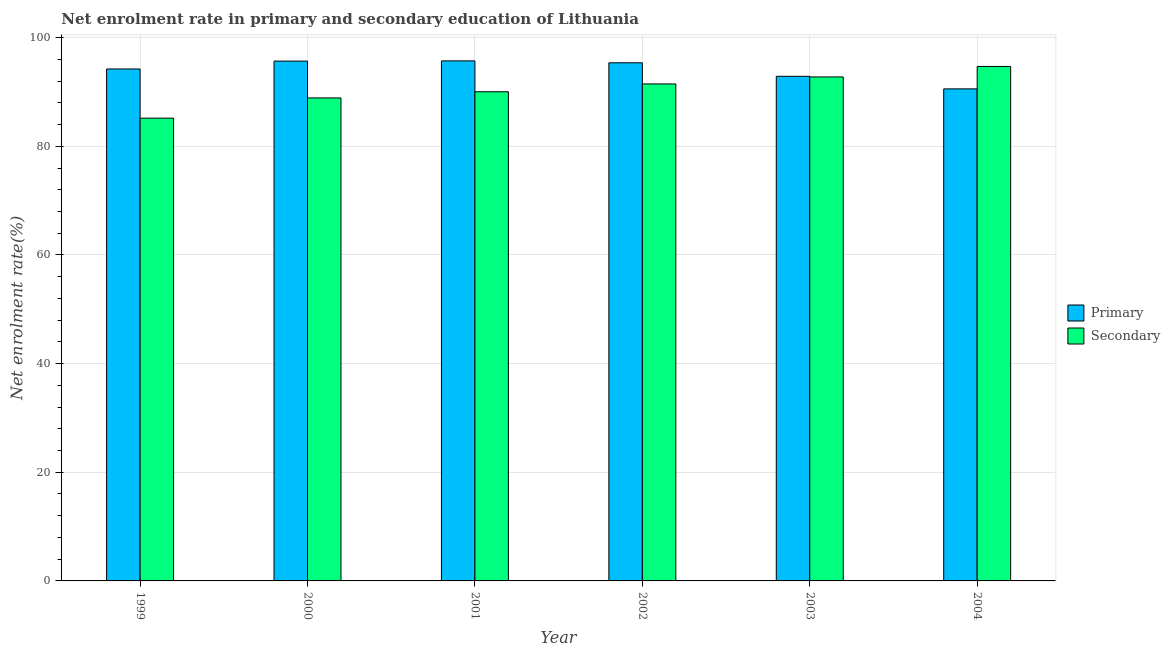How many groups of bars are there?
Offer a very short reply. 6. Are the number of bars per tick equal to the number of legend labels?
Provide a short and direct response. Yes. Are the number of bars on each tick of the X-axis equal?
Give a very brief answer. Yes. How many bars are there on the 2nd tick from the right?
Keep it short and to the point. 2. What is the label of the 4th group of bars from the left?
Offer a very short reply. 2002. In how many cases, is the number of bars for a given year not equal to the number of legend labels?
Give a very brief answer. 0. What is the enrollment rate in secondary education in 2002?
Offer a terse response. 91.47. Across all years, what is the maximum enrollment rate in primary education?
Make the answer very short. 95.72. Across all years, what is the minimum enrollment rate in primary education?
Your response must be concise. 90.56. In which year was the enrollment rate in secondary education maximum?
Offer a terse response. 2004. In which year was the enrollment rate in secondary education minimum?
Your answer should be compact. 1999. What is the total enrollment rate in primary education in the graph?
Offer a very short reply. 564.43. What is the difference between the enrollment rate in secondary education in 1999 and that in 2003?
Ensure brevity in your answer.  -7.59. What is the difference between the enrollment rate in secondary education in 2001 and the enrollment rate in primary education in 2002?
Give a very brief answer. -1.44. What is the average enrollment rate in primary education per year?
Provide a short and direct response. 94.07. In the year 2000, what is the difference between the enrollment rate in primary education and enrollment rate in secondary education?
Your response must be concise. 0. In how many years, is the enrollment rate in secondary education greater than 88 %?
Your response must be concise. 5. What is the ratio of the enrollment rate in secondary education in 2001 to that in 2003?
Your response must be concise. 0.97. Is the enrollment rate in primary education in 2000 less than that in 2001?
Provide a succinct answer. Yes. Is the difference between the enrollment rate in primary education in 2000 and 2004 greater than the difference between the enrollment rate in secondary education in 2000 and 2004?
Offer a very short reply. No. What is the difference between the highest and the second highest enrollment rate in secondary education?
Ensure brevity in your answer.  1.93. What is the difference between the highest and the lowest enrollment rate in secondary education?
Provide a succinct answer. 9.52. In how many years, is the enrollment rate in secondary education greater than the average enrollment rate in secondary education taken over all years?
Provide a succinct answer. 3. Is the sum of the enrollment rate in primary education in 2000 and 2001 greater than the maximum enrollment rate in secondary education across all years?
Provide a short and direct response. Yes. What does the 1st bar from the left in 2003 represents?
Offer a very short reply. Primary. What does the 2nd bar from the right in 2003 represents?
Your answer should be very brief. Primary. Are all the bars in the graph horizontal?
Your answer should be very brief. No. What is the difference between two consecutive major ticks on the Y-axis?
Your answer should be very brief. 20. Does the graph contain any zero values?
Provide a succinct answer. No. Where does the legend appear in the graph?
Keep it short and to the point. Center right. How many legend labels are there?
Ensure brevity in your answer.  2. What is the title of the graph?
Offer a very short reply. Net enrolment rate in primary and secondary education of Lithuania. What is the label or title of the Y-axis?
Your answer should be compact. Net enrolment rate(%). What is the Net enrolment rate(%) in Primary in 1999?
Your answer should be compact. 94.23. What is the Net enrolment rate(%) in Secondary in 1999?
Your answer should be very brief. 85.17. What is the Net enrolment rate(%) of Primary in 2000?
Provide a succinct answer. 95.68. What is the Net enrolment rate(%) in Secondary in 2000?
Provide a short and direct response. 88.9. What is the Net enrolment rate(%) of Primary in 2001?
Make the answer very short. 95.72. What is the Net enrolment rate(%) of Secondary in 2001?
Give a very brief answer. 90.03. What is the Net enrolment rate(%) in Primary in 2002?
Ensure brevity in your answer.  95.37. What is the Net enrolment rate(%) in Secondary in 2002?
Your answer should be very brief. 91.47. What is the Net enrolment rate(%) of Primary in 2003?
Ensure brevity in your answer.  92.88. What is the Net enrolment rate(%) of Secondary in 2003?
Make the answer very short. 92.76. What is the Net enrolment rate(%) in Primary in 2004?
Offer a terse response. 90.56. What is the Net enrolment rate(%) in Secondary in 2004?
Your answer should be very brief. 94.69. Across all years, what is the maximum Net enrolment rate(%) in Primary?
Provide a short and direct response. 95.72. Across all years, what is the maximum Net enrolment rate(%) in Secondary?
Make the answer very short. 94.69. Across all years, what is the minimum Net enrolment rate(%) in Primary?
Your answer should be very brief. 90.56. Across all years, what is the minimum Net enrolment rate(%) in Secondary?
Offer a very short reply. 85.17. What is the total Net enrolment rate(%) in Primary in the graph?
Ensure brevity in your answer.  564.43. What is the total Net enrolment rate(%) in Secondary in the graph?
Your answer should be compact. 543.03. What is the difference between the Net enrolment rate(%) in Primary in 1999 and that in 2000?
Your response must be concise. -1.45. What is the difference between the Net enrolment rate(%) of Secondary in 1999 and that in 2000?
Keep it short and to the point. -3.73. What is the difference between the Net enrolment rate(%) of Primary in 1999 and that in 2001?
Ensure brevity in your answer.  -1.49. What is the difference between the Net enrolment rate(%) in Secondary in 1999 and that in 2001?
Your answer should be compact. -4.86. What is the difference between the Net enrolment rate(%) of Primary in 1999 and that in 2002?
Your answer should be very brief. -1.14. What is the difference between the Net enrolment rate(%) in Secondary in 1999 and that in 2002?
Keep it short and to the point. -6.3. What is the difference between the Net enrolment rate(%) in Primary in 1999 and that in 2003?
Offer a very short reply. 1.35. What is the difference between the Net enrolment rate(%) in Secondary in 1999 and that in 2003?
Keep it short and to the point. -7.59. What is the difference between the Net enrolment rate(%) in Primary in 1999 and that in 2004?
Provide a succinct answer. 3.66. What is the difference between the Net enrolment rate(%) of Secondary in 1999 and that in 2004?
Ensure brevity in your answer.  -9.52. What is the difference between the Net enrolment rate(%) in Primary in 2000 and that in 2001?
Provide a short and direct response. -0.04. What is the difference between the Net enrolment rate(%) of Secondary in 2000 and that in 2001?
Offer a terse response. -1.14. What is the difference between the Net enrolment rate(%) of Primary in 2000 and that in 2002?
Your answer should be very brief. 0.31. What is the difference between the Net enrolment rate(%) of Secondary in 2000 and that in 2002?
Your answer should be very brief. -2.57. What is the difference between the Net enrolment rate(%) of Primary in 2000 and that in 2003?
Keep it short and to the point. 2.8. What is the difference between the Net enrolment rate(%) in Secondary in 2000 and that in 2003?
Provide a succinct answer. -3.86. What is the difference between the Net enrolment rate(%) of Primary in 2000 and that in 2004?
Keep it short and to the point. 5.11. What is the difference between the Net enrolment rate(%) in Secondary in 2000 and that in 2004?
Give a very brief answer. -5.79. What is the difference between the Net enrolment rate(%) of Primary in 2001 and that in 2002?
Ensure brevity in your answer.  0.35. What is the difference between the Net enrolment rate(%) of Secondary in 2001 and that in 2002?
Provide a succinct answer. -1.44. What is the difference between the Net enrolment rate(%) in Primary in 2001 and that in 2003?
Provide a succinct answer. 2.84. What is the difference between the Net enrolment rate(%) in Secondary in 2001 and that in 2003?
Provide a succinct answer. -2.73. What is the difference between the Net enrolment rate(%) of Primary in 2001 and that in 2004?
Give a very brief answer. 5.16. What is the difference between the Net enrolment rate(%) of Secondary in 2001 and that in 2004?
Provide a succinct answer. -4.65. What is the difference between the Net enrolment rate(%) in Primary in 2002 and that in 2003?
Offer a very short reply. 2.49. What is the difference between the Net enrolment rate(%) of Secondary in 2002 and that in 2003?
Keep it short and to the point. -1.29. What is the difference between the Net enrolment rate(%) of Primary in 2002 and that in 2004?
Ensure brevity in your answer.  4.8. What is the difference between the Net enrolment rate(%) in Secondary in 2002 and that in 2004?
Keep it short and to the point. -3.22. What is the difference between the Net enrolment rate(%) of Primary in 2003 and that in 2004?
Your answer should be very brief. 2.32. What is the difference between the Net enrolment rate(%) in Secondary in 2003 and that in 2004?
Offer a terse response. -1.93. What is the difference between the Net enrolment rate(%) of Primary in 1999 and the Net enrolment rate(%) of Secondary in 2000?
Offer a terse response. 5.33. What is the difference between the Net enrolment rate(%) of Primary in 1999 and the Net enrolment rate(%) of Secondary in 2001?
Your answer should be compact. 4.19. What is the difference between the Net enrolment rate(%) in Primary in 1999 and the Net enrolment rate(%) in Secondary in 2002?
Provide a succinct answer. 2.75. What is the difference between the Net enrolment rate(%) of Primary in 1999 and the Net enrolment rate(%) of Secondary in 2003?
Make the answer very short. 1.46. What is the difference between the Net enrolment rate(%) of Primary in 1999 and the Net enrolment rate(%) of Secondary in 2004?
Give a very brief answer. -0.46. What is the difference between the Net enrolment rate(%) in Primary in 2000 and the Net enrolment rate(%) in Secondary in 2001?
Give a very brief answer. 5.64. What is the difference between the Net enrolment rate(%) of Primary in 2000 and the Net enrolment rate(%) of Secondary in 2002?
Your response must be concise. 4.2. What is the difference between the Net enrolment rate(%) in Primary in 2000 and the Net enrolment rate(%) in Secondary in 2003?
Make the answer very short. 2.91. What is the difference between the Net enrolment rate(%) in Primary in 2000 and the Net enrolment rate(%) in Secondary in 2004?
Ensure brevity in your answer.  0.99. What is the difference between the Net enrolment rate(%) in Primary in 2001 and the Net enrolment rate(%) in Secondary in 2002?
Give a very brief answer. 4.25. What is the difference between the Net enrolment rate(%) in Primary in 2001 and the Net enrolment rate(%) in Secondary in 2003?
Your answer should be very brief. 2.96. What is the difference between the Net enrolment rate(%) of Primary in 2001 and the Net enrolment rate(%) of Secondary in 2004?
Ensure brevity in your answer.  1.03. What is the difference between the Net enrolment rate(%) of Primary in 2002 and the Net enrolment rate(%) of Secondary in 2003?
Provide a short and direct response. 2.6. What is the difference between the Net enrolment rate(%) of Primary in 2002 and the Net enrolment rate(%) of Secondary in 2004?
Offer a terse response. 0.68. What is the difference between the Net enrolment rate(%) in Primary in 2003 and the Net enrolment rate(%) in Secondary in 2004?
Make the answer very short. -1.81. What is the average Net enrolment rate(%) in Primary per year?
Give a very brief answer. 94.07. What is the average Net enrolment rate(%) in Secondary per year?
Give a very brief answer. 90.51. In the year 1999, what is the difference between the Net enrolment rate(%) in Primary and Net enrolment rate(%) in Secondary?
Ensure brevity in your answer.  9.05. In the year 2000, what is the difference between the Net enrolment rate(%) in Primary and Net enrolment rate(%) in Secondary?
Make the answer very short. 6.78. In the year 2001, what is the difference between the Net enrolment rate(%) of Primary and Net enrolment rate(%) of Secondary?
Make the answer very short. 5.68. In the year 2002, what is the difference between the Net enrolment rate(%) in Primary and Net enrolment rate(%) in Secondary?
Your response must be concise. 3.89. In the year 2003, what is the difference between the Net enrolment rate(%) of Primary and Net enrolment rate(%) of Secondary?
Offer a terse response. 0.12. In the year 2004, what is the difference between the Net enrolment rate(%) of Primary and Net enrolment rate(%) of Secondary?
Your answer should be compact. -4.13. What is the ratio of the Net enrolment rate(%) of Primary in 1999 to that in 2000?
Give a very brief answer. 0.98. What is the ratio of the Net enrolment rate(%) of Secondary in 1999 to that in 2000?
Give a very brief answer. 0.96. What is the ratio of the Net enrolment rate(%) in Primary in 1999 to that in 2001?
Keep it short and to the point. 0.98. What is the ratio of the Net enrolment rate(%) in Secondary in 1999 to that in 2001?
Make the answer very short. 0.95. What is the ratio of the Net enrolment rate(%) in Secondary in 1999 to that in 2002?
Provide a succinct answer. 0.93. What is the ratio of the Net enrolment rate(%) of Primary in 1999 to that in 2003?
Your answer should be compact. 1.01. What is the ratio of the Net enrolment rate(%) of Secondary in 1999 to that in 2003?
Offer a very short reply. 0.92. What is the ratio of the Net enrolment rate(%) in Primary in 1999 to that in 2004?
Provide a short and direct response. 1.04. What is the ratio of the Net enrolment rate(%) of Secondary in 1999 to that in 2004?
Your answer should be very brief. 0.9. What is the ratio of the Net enrolment rate(%) in Primary in 2000 to that in 2001?
Keep it short and to the point. 1. What is the ratio of the Net enrolment rate(%) of Secondary in 2000 to that in 2001?
Keep it short and to the point. 0.99. What is the ratio of the Net enrolment rate(%) of Secondary in 2000 to that in 2002?
Ensure brevity in your answer.  0.97. What is the ratio of the Net enrolment rate(%) of Primary in 2000 to that in 2003?
Make the answer very short. 1.03. What is the ratio of the Net enrolment rate(%) of Secondary in 2000 to that in 2003?
Your answer should be very brief. 0.96. What is the ratio of the Net enrolment rate(%) in Primary in 2000 to that in 2004?
Your response must be concise. 1.06. What is the ratio of the Net enrolment rate(%) of Secondary in 2000 to that in 2004?
Offer a very short reply. 0.94. What is the ratio of the Net enrolment rate(%) in Secondary in 2001 to that in 2002?
Provide a short and direct response. 0.98. What is the ratio of the Net enrolment rate(%) in Primary in 2001 to that in 2003?
Provide a succinct answer. 1.03. What is the ratio of the Net enrolment rate(%) in Secondary in 2001 to that in 2003?
Provide a short and direct response. 0.97. What is the ratio of the Net enrolment rate(%) in Primary in 2001 to that in 2004?
Your answer should be compact. 1.06. What is the ratio of the Net enrolment rate(%) in Secondary in 2001 to that in 2004?
Your response must be concise. 0.95. What is the ratio of the Net enrolment rate(%) of Primary in 2002 to that in 2003?
Keep it short and to the point. 1.03. What is the ratio of the Net enrolment rate(%) in Secondary in 2002 to that in 2003?
Your response must be concise. 0.99. What is the ratio of the Net enrolment rate(%) of Primary in 2002 to that in 2004?
Your response must be concise. 1.05. What is the ratio of the Net enrolment rate(%) of Primary in 2003 to that in 2004?
Your answer should be compact. 1.03. What is the ratio of the Net enrolment rate(%) in Secondary in 2003 to that in 2004?
Your response must be concise. 0.98. What is the difference between the highest and the second highest Net enrolment rate(%) of Primary?
Offer a terse response. 0.04. What is the difference between the highest and the second highest Net enrolment rate(%) in Secondary?
Make the answer very short. 1.93. What is the difference between the highest and the lowest Net enrolment rate(%) of Primary?
Provide a short and direct response. 5.16. What is the difference between the highest and the lowest Net enrolment rate(%) of Secondary?
Ensure brevity in your answer.  9.52. 